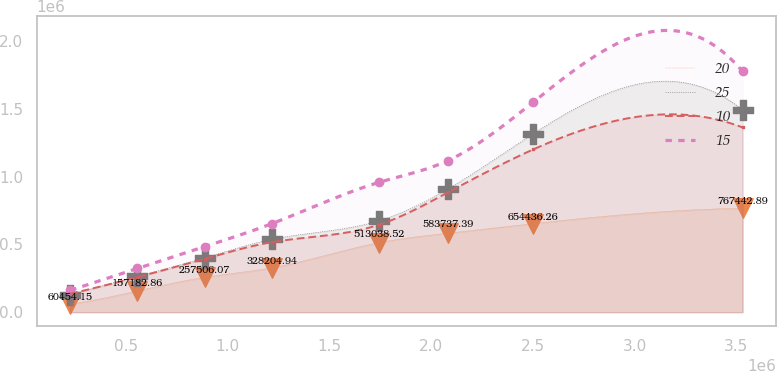<chart> <loc_0><loc_0><loc_500><loc_500><line_chart><ecel><fcel>20<fcel>25<fcel>10<fcel>15<nl><fcel>225702<fcel>60454.2<fcel>127941<fcel>136169<fcel>161213<nl><fcel>556212<fcel>157183<fcel>264517<fcel>258935<fcel>322840<nl><fcel>886723<fcel>257506<fcel>401093<fcel>394051<fcel>484468<nl><fcel>1.21723e+06<fcel>328205<fcel>537669<fcel>516817<fcel>653842<nl><fcel>1.74209e+06<fcel>513039<fcel>674245<fcel>644777<fcel>957784<nl><fcel>2.08282e+06<fcel>583737<fcel>909348<fcel>884429<fcel>1.11941e+06<nl><fcel>2.50227e+06<fcel>654436<fcel>1.31778e+06<fcel>1.20197e+06<fcel>1.55119e+06<nl><fcel>3.53081e+06<fcel>767443<fcel>1.4937e+06<fcel>1.36383e+06<fcel>1.77749e+06<nl></chart> 